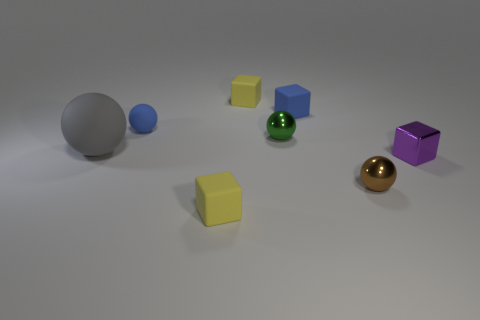How many objects are there in the image, and can you describe them? There are seven objects in the image. Starting from the left, we see a large gray sphere, a smaller blue sphere, a small yellow cube, a small green cube, a small blue cube, a golden reflective sphere, and finally, a purple cube. Which object appears to be the closest to the camera? The yellow cube positioned at the center front appears to be the closest to the camera. 